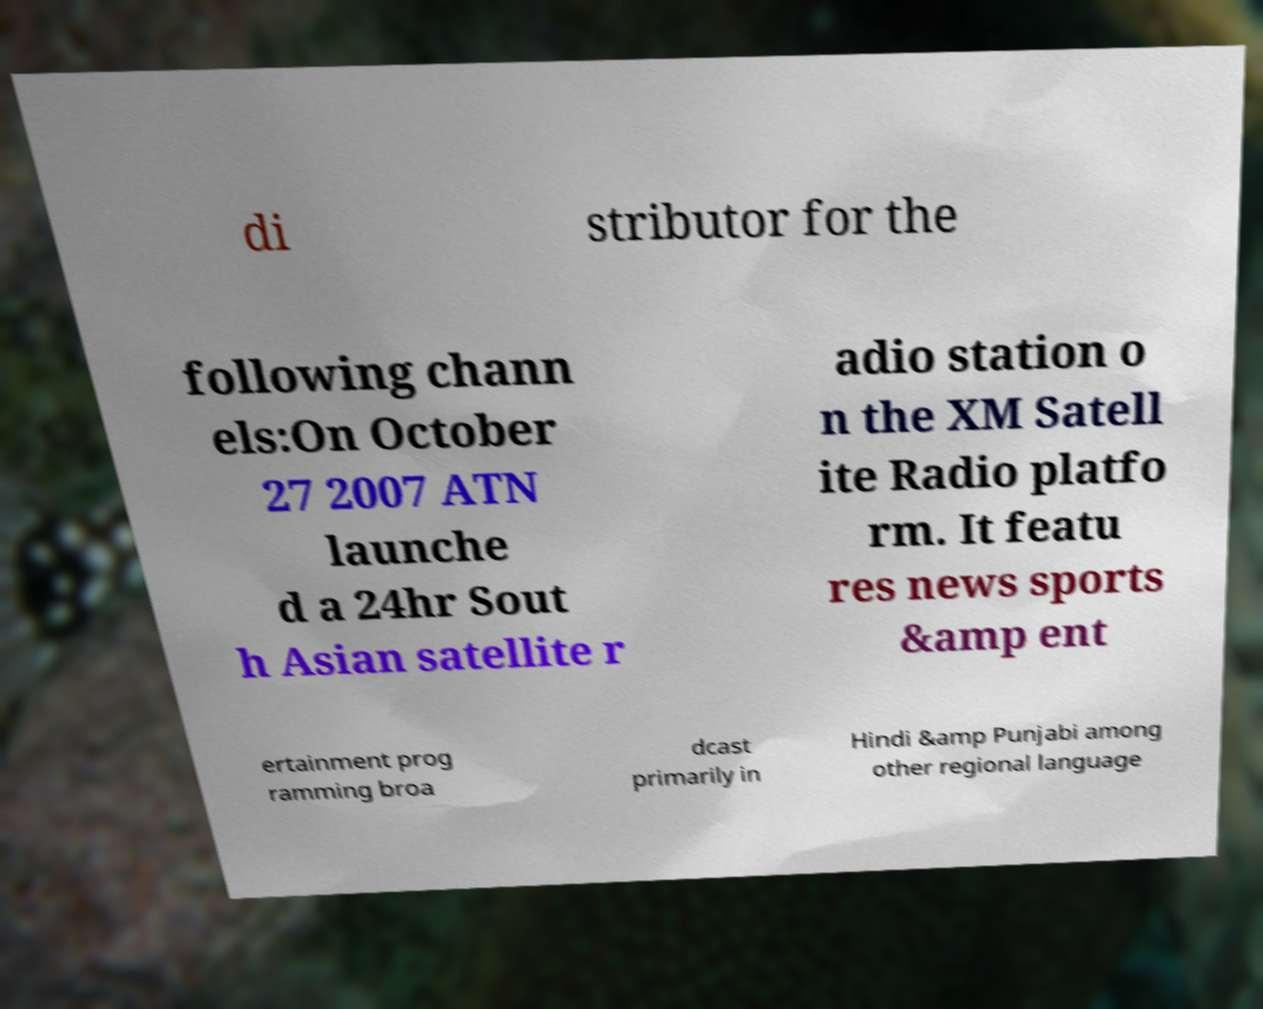What messages or text are displayed in this image? I need them in a readable, typed format. di stributor for the following chann els:On October 27 2007 ATN launche d a 24hr Sout h Asian satellite r adio station o n the XM Satell ite Radio platfo rm. It featu res news sports &amp ent ertainment prog ramming broa dcast primarily in Hindi &amp Punjabi among other regional language 